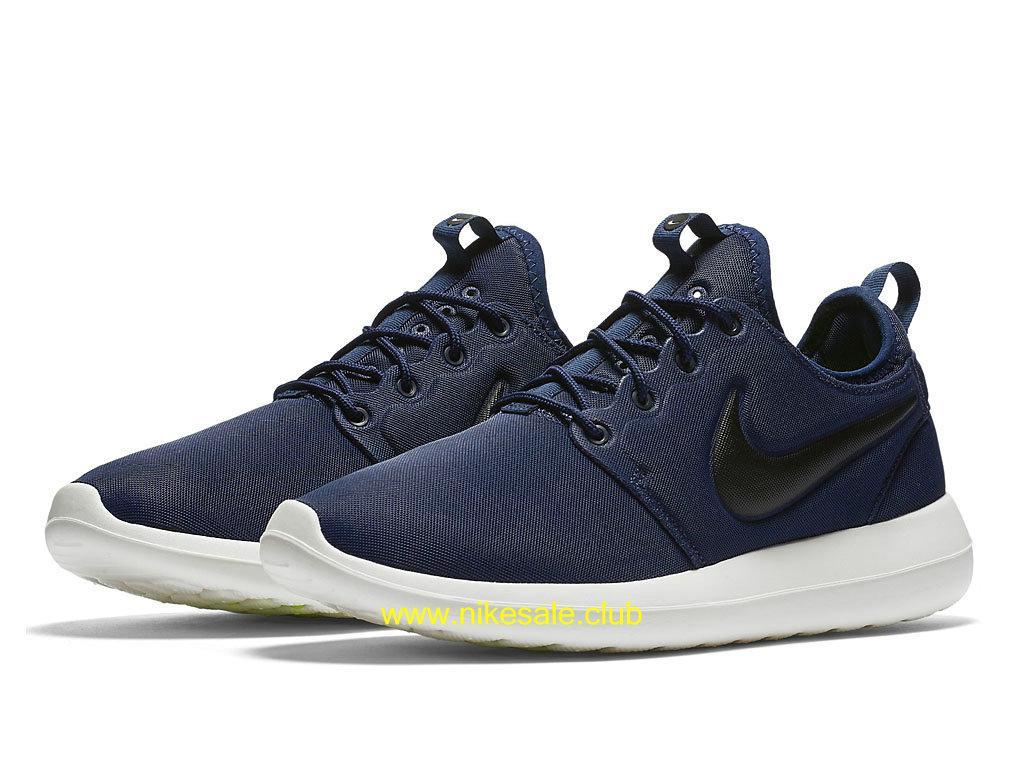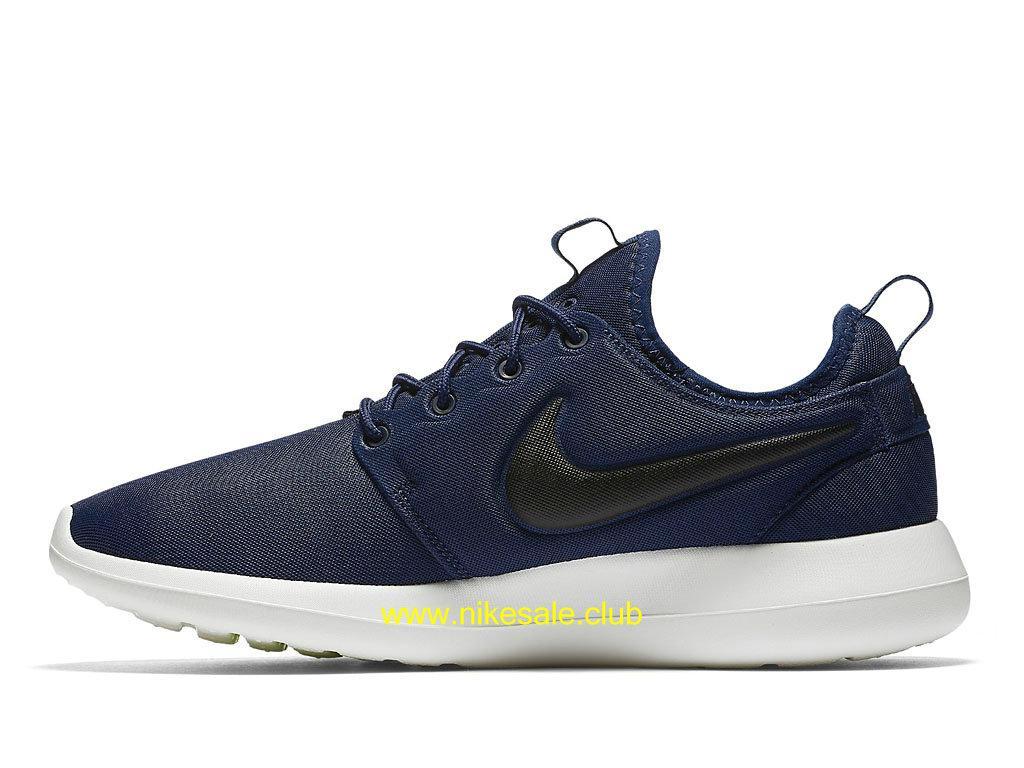The first image is the image on the left, the second image is the image on the right. Given the left and right images, does the statement "The combined images show exactly two left-facing sneakers." hold true? Answer yes or no. No. The first image is the image on the left, the second image is the image on the right. Analyze the images presented: Is the assertion "There are two shoes, and one of them is striped, while the other is a plain color." valid? Answer yes or no. No. 